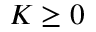Convert formula to latex. <formula><loc_0><loc_0><loc_500><loc_500>K \geq 0</formula> 